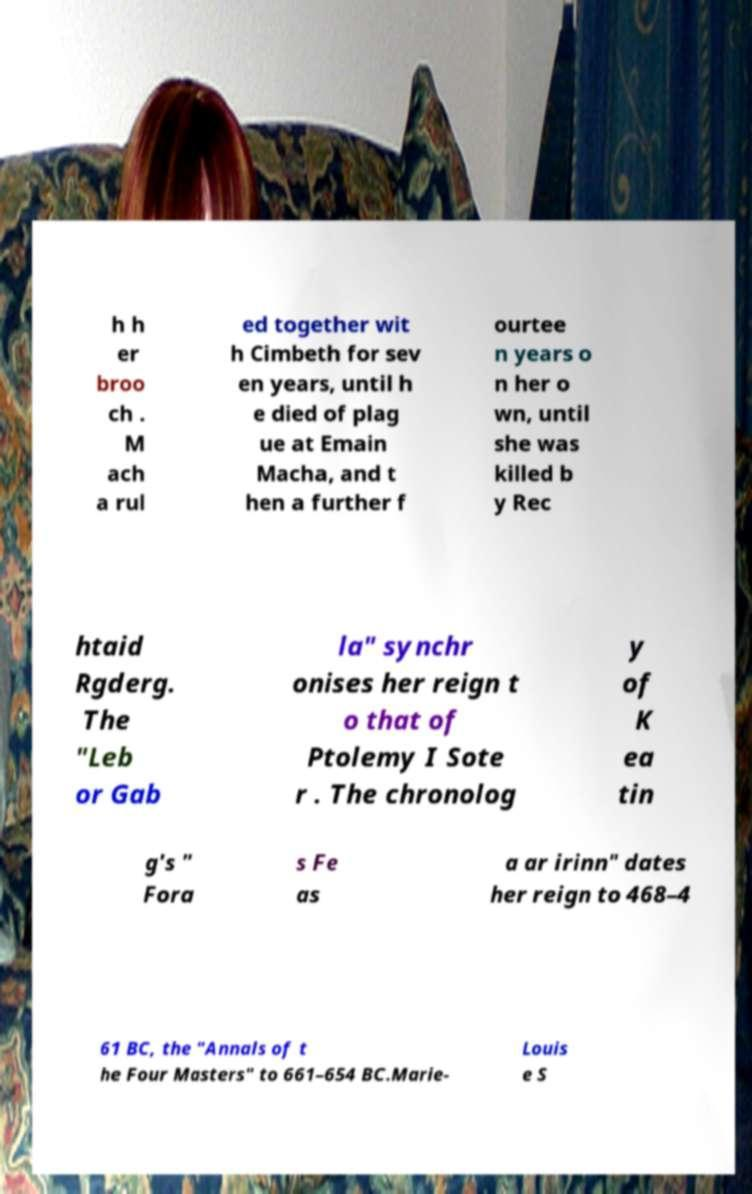There's text embedded in this image that I need extracted. Can you transcribe it verbatim? h h er broo ch . M ach a rul ed together wit h Cimbeth for sev en years, until h e died of plag ue at Emain Macha, and t hen a further f ourtee n years o n her o wn, until she was killed b y Rec htaid Rgderg. The "Leb or Gab la" synchr onises her reign t o that of Ptolemy I Sote r . The chronolog y of K ea tin g's " Fora s Fe as a ar irinn" dates her reign to 468–4 61 BC, the "Annals of t he Four Masters" to 661–654 BC.Marie- Louis e S 